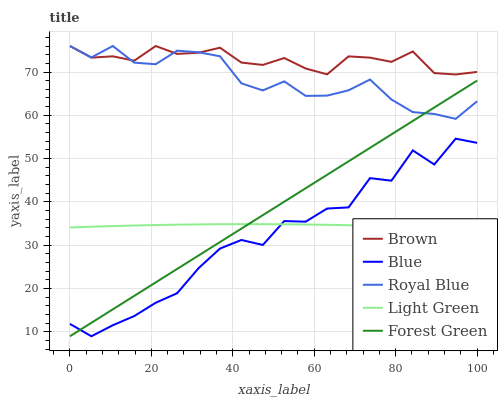Does Blue have the minimum area under the curve?
Answer yes or no. Yes. Does Brown have the maximum area under the curve?
Answer yes or no. Yes. Does Forest Green have the minimum area under the curve?
Answer yes or no. No. Does Forest Green have the maximum area under the curve?
Answer yes or no. No. Is Forest Green the smoothest?
Answer yes or no. Yes. Is Blue the roughest?
Answer yes or no. Yes. Is Brown the smoothest?
Answer yes or no. No. Is Brown the roughest?
Answer yes or no. No. Does Blue have the lowest value?
Answer yes or no. Yes. Does Brown have the lowest value?
Answer yes or no. No. Does Royal Blue have the highest value?
Answer yes or no. Yes. Does Forest Green have the highest value?
Answer yes or no. No. Is Light Green less than Royal Blue?
Answer yes or no. Yes. Is Royal Blue greater than Blue?
Answer yes or no. Yes. Does Royal Blue intersect Brown?
Answer yes or no. Yes. Is Royal Blue less than Brown?
Answer yes or no. No. Is Royal Blue greater than Brown?
Answer yes or no. No. Does Light Green intersect Royal Blue?
Answer yes or no. No. 